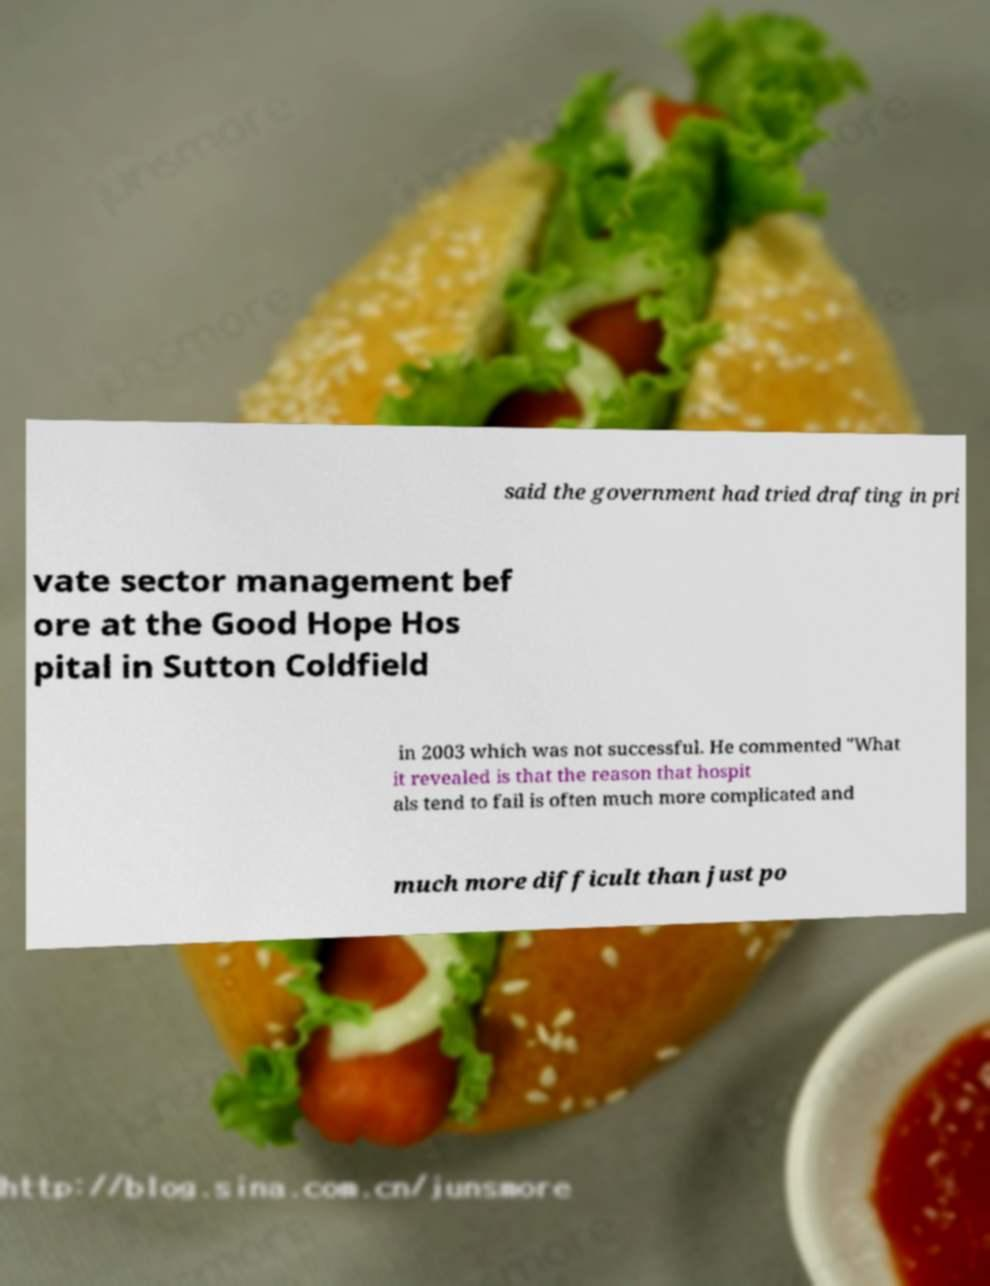Please read and relay the text visible in this image. What does it say? said the government had tried drafting in pri vate sector management bef ore at the Good Hope Hos pital in Sutton Coldfield in 2003 which was not successful. He commented "What it revealed is that the reason that hospit als tend to fail is often much more complicated and much more difficult than just po 